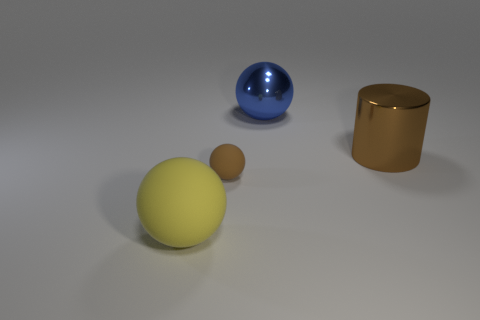There is a tiny brown sphere; are there any shiny spheres on the left side of it?
Provide a short and direct response. No. Is there a gray cylinder made of the same material as the blue sphere?
Make the answer very short. No. What size is the thing that is the same color as the big cylinder?
Your answer should be compact. Small. How many cylinders are either brown objects or tiny rubber objects?
Give a very brief answer. 1. Are there more shiny cylinders to the left of the tiny rubber object than big brown shiny things that are behind the large yellow sphere?
Offer a terse response. No. How many metal things have the same color as the big metal sphere?
Your response must be concise. 0. The other sphere that is the same material as the yellow ball is what size?
Offer a very short reply. Small. What number of objects are either big spheres that are on the right side of the large yellow thing or brown metallic cylinders?
Your answer should be compact. 2. Does the large sphere that is in front of the large brown object have the same color as the big shiny cylinder?
Your answer should be compact. No. There is a yellow thing that is the same shape as the brown rubber thing; what is its size?
Ensure brevity in your answer.  Large. 